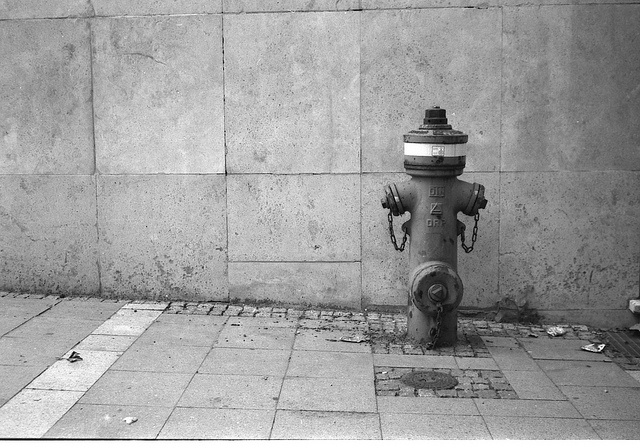Describe the objects in this image and their specific colors. I can see a fire hydrant in darkgray, black, gray, and white tones in this image. 